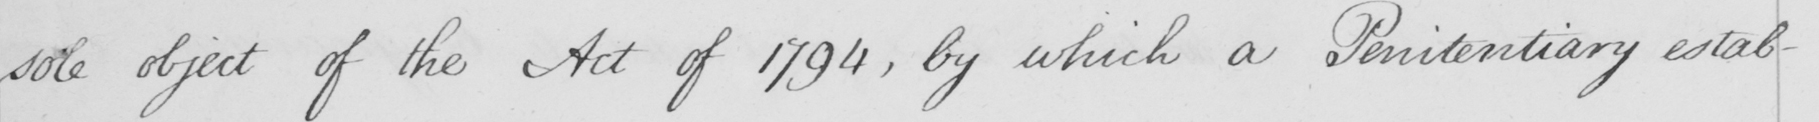Can you read and transcribe this handwriting? the sole object of the Act of 1794 , by which a Penitentiary estab- 